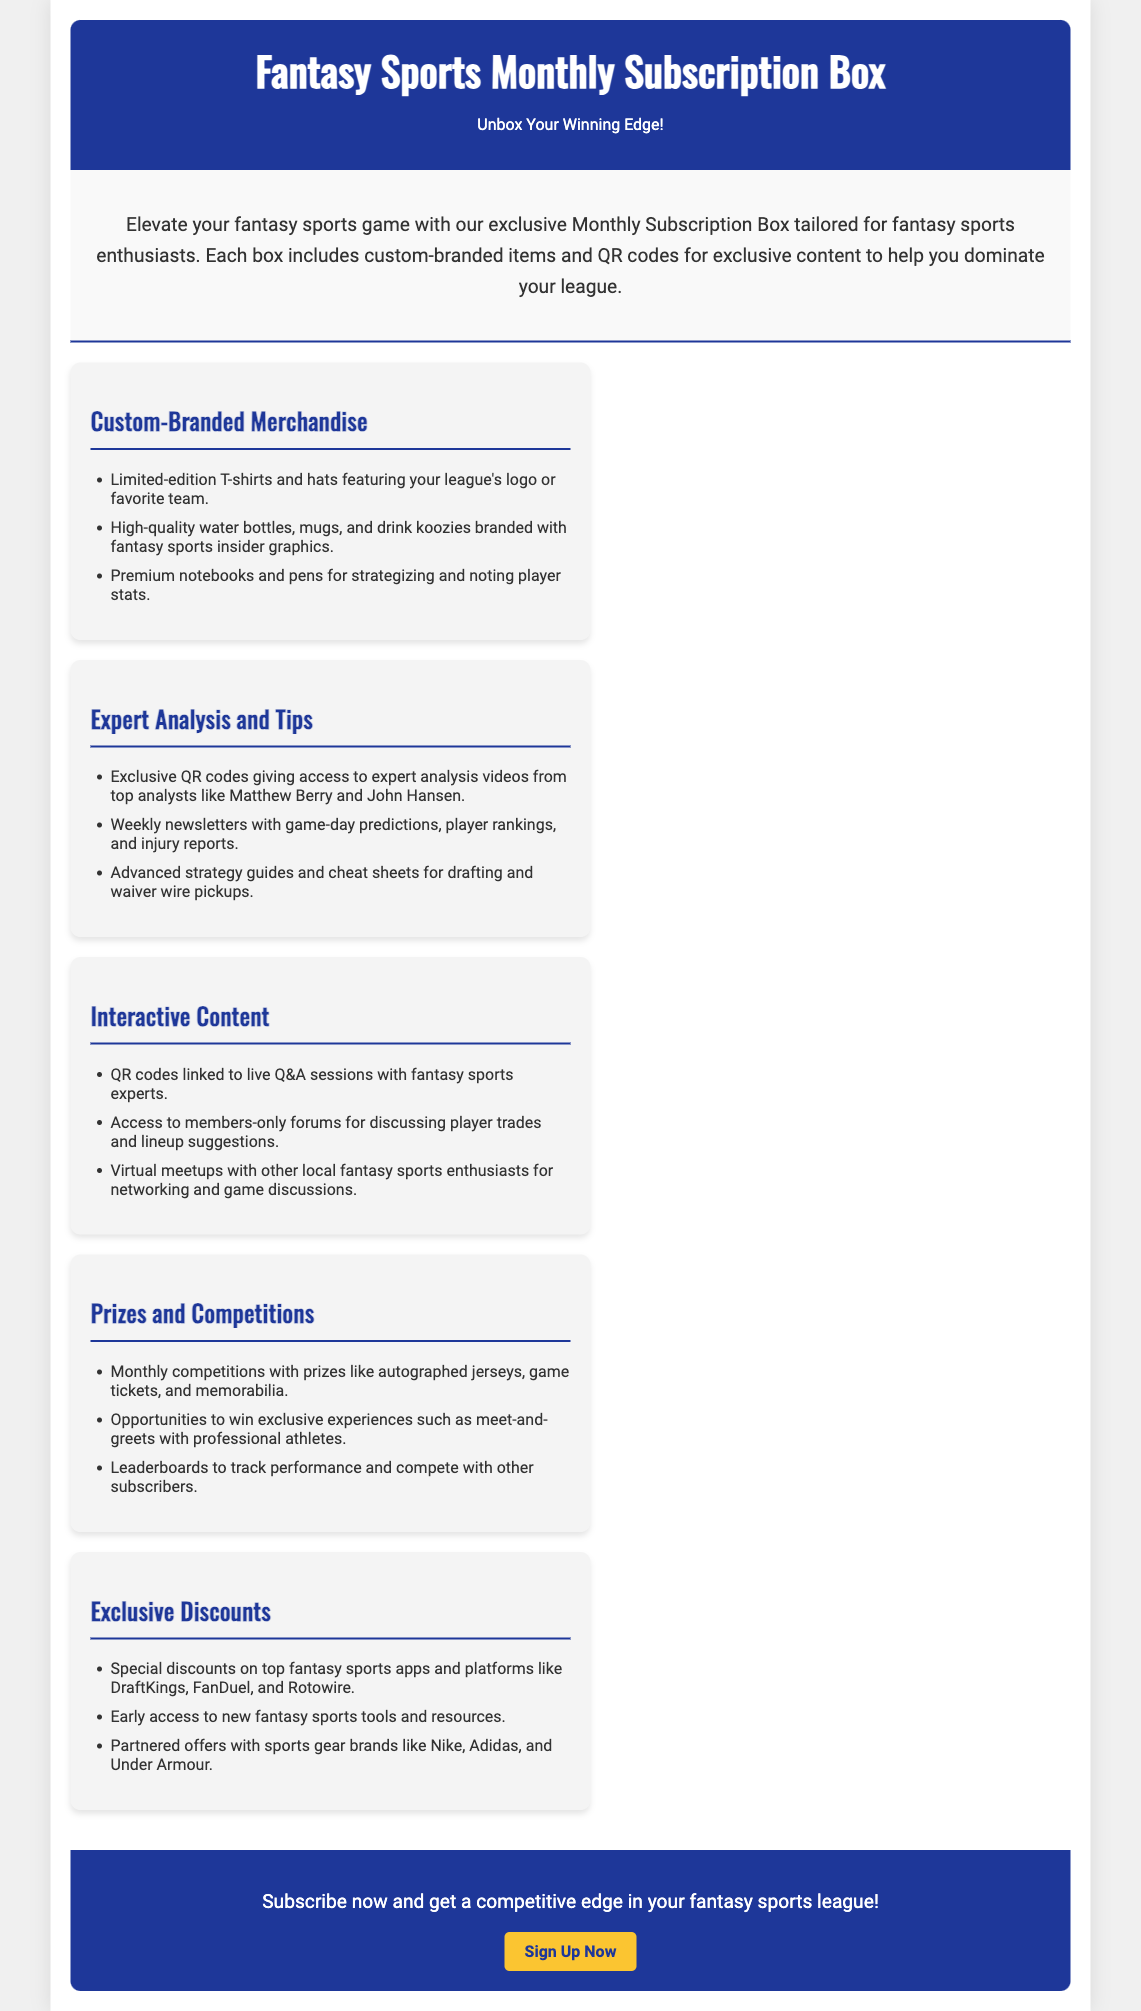What is the primary focus of the subscription box? The main focus is on providing exclusive content and merchandise for fantasy sports enthusiasts.
Answer: Exclusive content and merchandise for fantasy sports enthusiasts How many features are listed in the document? The document mentions a total of five distinct features related to the subscription box.
Answer: Five Who are the experts mentioned for analysis tips? The document lists specific analysts who provide expert analysis through exclusive content.
Answer: Matthew Berry and John Hansen What kind of items are included in the Custom-Branded Merchandise? The document provides examples of merchandise that are customized for the subscribers.
Answer: T-shirts, hats, water bottles, mugs, and drink koozies What types of competitions are associated with the subscription box? The document describes opportunities for subscribers to compete for prizes and special experiences.
Answer: Monthly competitions with prizes and exclusive experiences Which sports brands are mentioned for exclusive discounts? The document outlines partnerships that provide discounts on popular sports brands.
Answer: Nike, Adidas, and Under Armour What is one way subscribers can interact with fantasy sports experts? The document highlights a method for subscribers to engage with experts in real-time.
Answer: Live Q&A sessions What is the call to action at the end of the document? The document encourages action from potential subscribers to enhance their fantasy sports experience.
Answer: Subscribe now and get a competitive edge 